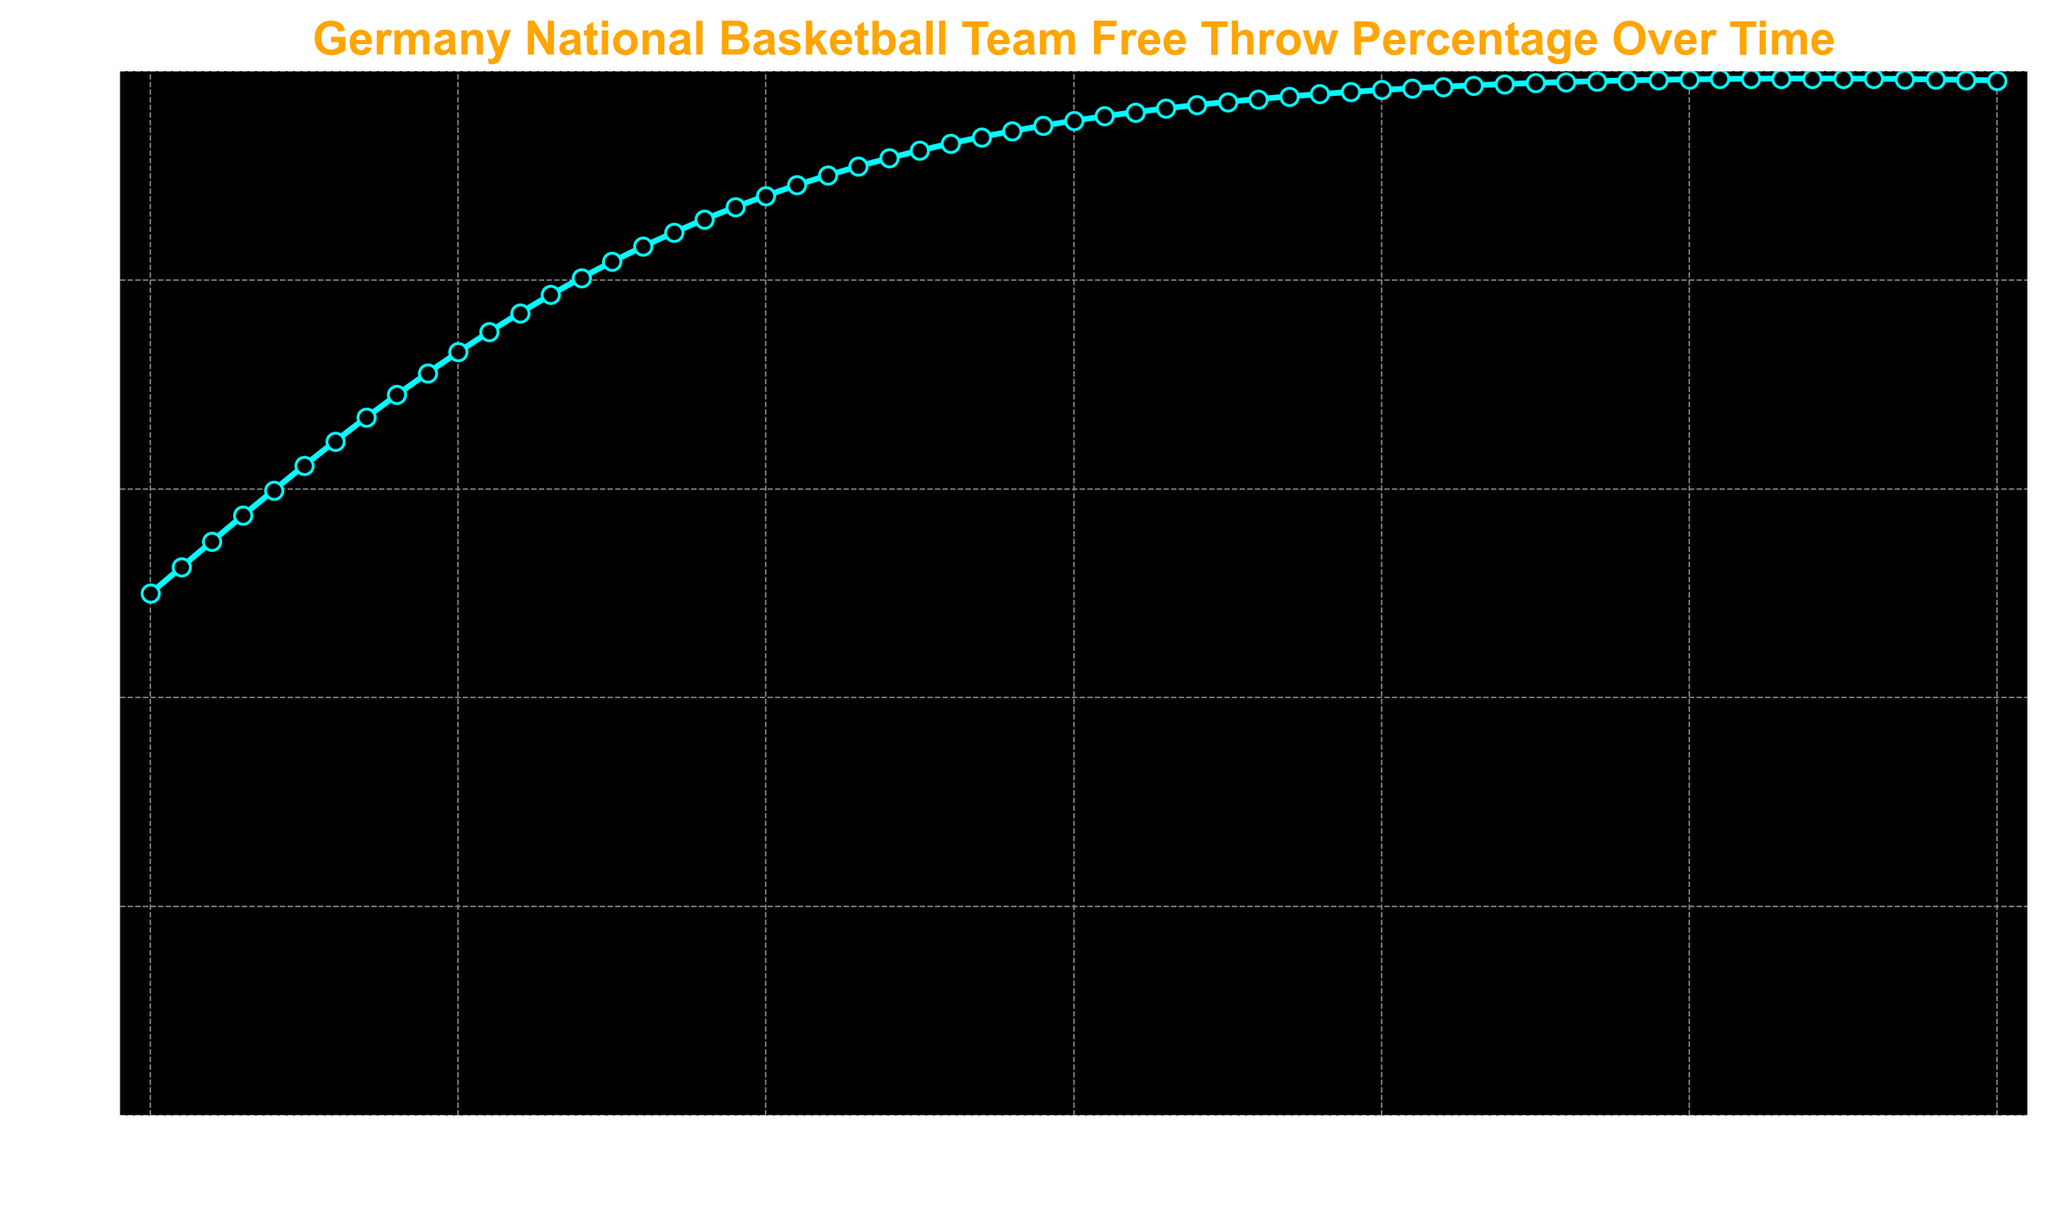What is the free throw percentage at time 20? Find time 20 on the x-axis and follow it up to intersect with the curve, then read the corresponding value on the y-axis. The free throw percentage at time 20 is 0.8807970779.
Answer: 0.88 At which time does the free throw percentage first exceed 0.75? Locate the point on the curve where the y-value first goes above 0.75 and read the corresponding x-axis value. The curve exceeds 0.75 for the first time between time 10 and 11.
Answer: 11 What is the difference in free throw percentage between time 10 and time 30? Find the free throw percentages for time 10 and time 30 and subtract the earlier value from the later value. Time 10: 0.7310585786, Time 30: 0.9525741268. Difference = 0.9525741268 - 0.7310585786 = 0.2215155482.
Answer: 0.22 At what time is the free throw percentage closest to 0.60? Examine the curve and find the point where the free throw percentage is nearest to 0.60 by looking at values around this percentage. Time 4: 0.5986876601 is closest to 0.60.
Answer: 4 What is the average free throw percentage from time 5 to time 10? Sum the free throw percentages from time 5 to time 10, then divide by the number of data points (6). Values: 0.6224593312 + 0.6456563062 + 0.6681877722 + 0.6899744811 + 0.7109495026 + 0.7310585786 = 4.068286972. Average = 4.068286972 / 6 = 0.6780478287.
Answer: 0.68 How does the free throw percentage change between time 30 and time 50? Compare the free throw percentage values at times 30 and 50. Time 30: 0.9525741268, Time 50: 0.992253976. The percentage increases from 0.9525741268 to 0.992253976.
Answer: Increases What color is the line representing the free throw percentage in the plot? Observe the color used for the curve connecting data points in the graph. The line is cyan.
Answer: Cyan Which time has a higher free throw percentage, time 15 or time 35? Find the free throw percentages at times 15 and 35 and compare them. Time 15: 0.8175744762, Time 35: 0.9706877693. Time 35 has the higher percentage.
Answer: Time 35 What is the trend of free throw percentage from time 0 to time 10? Observe how the curve progresses from time 0 to time 10. The free throw percentage shows an increasing trend over this period.
Answer: Increasing 